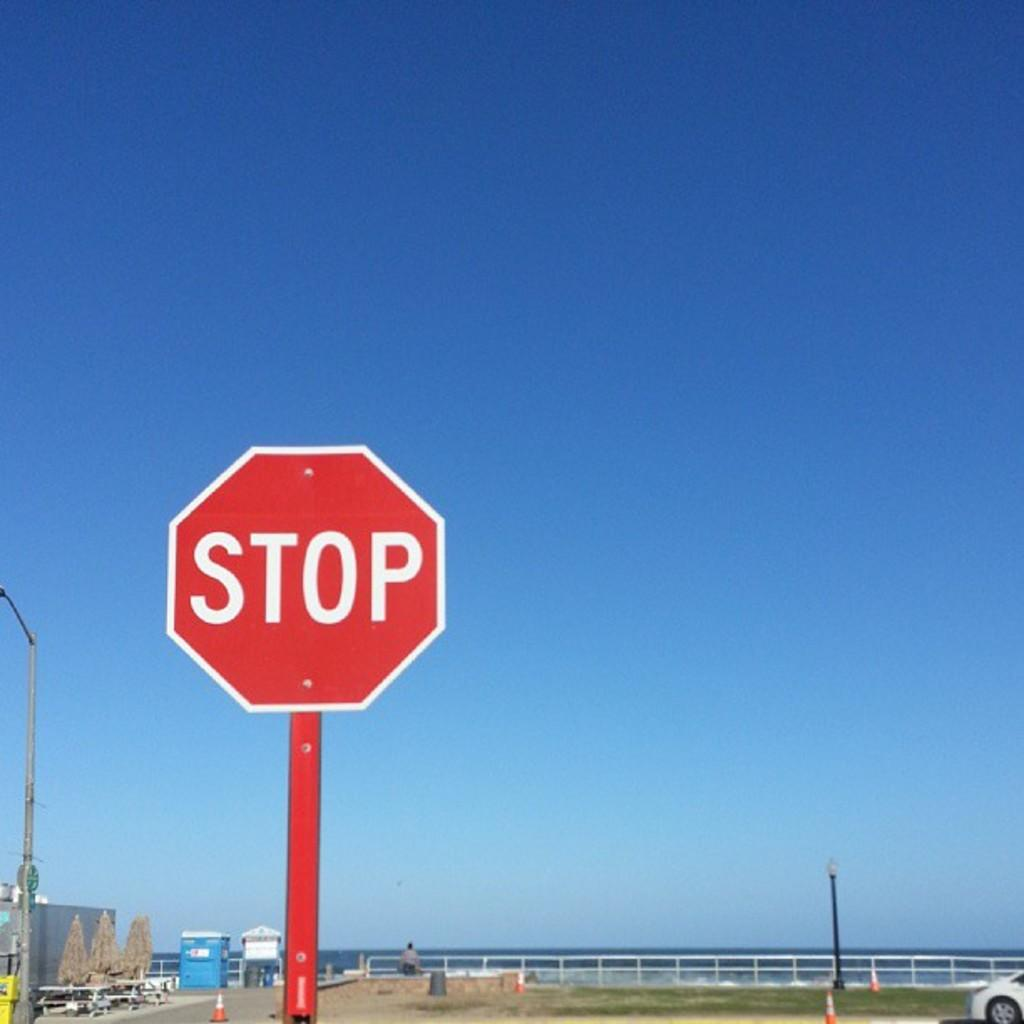<image>
Share a concise interpretation of the image provided. A stop sign on a red pole against a flawless blue sky. 